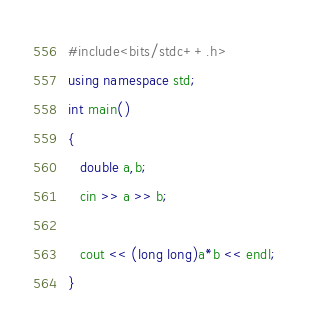<code> <loc_0><loc_0><loc_500><loc_500><_C++_>#include<bits/stdc++.h>
using namespace std;
int main()
{
   double a,b;
   cin >> a >> b;

   cout << (long long)a*b << endl;
}
</code> 